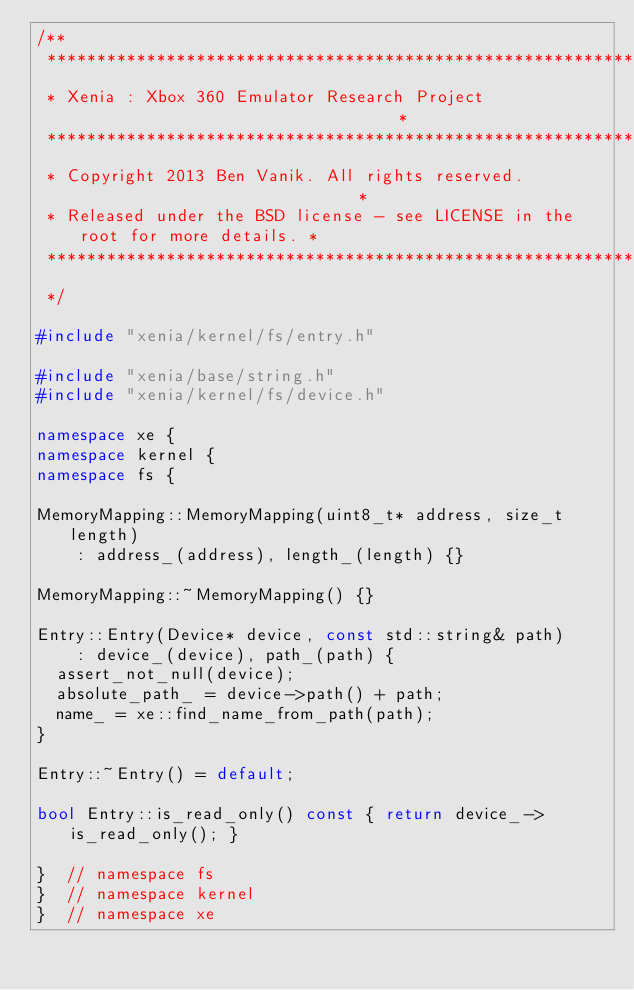Convert code to text. <code><loc_0><loc_0><loc_500><loc_500><_C++_>/**
 ******************************************************************************
 * Xenia : Xbox 360 Emulator Research Project                                 *
 ******************************************************************************
 * Copyright 2013 Ben Vanik. All rights reserved.                             *
 * Released under the BSD license - see LICENSE in the root for more details. *
 ******************************************************************************
 */

#include "xenia/kernel/fs/entry.h"

#include "xenia/base/string.h"
#include "xenia/kernel/fs/device.h"

namespace xe {
namespace kernel {
namespace fs {

MemoryMapping::MemoryMapping(uint8_t* address, size_t length)
    : address_(address), length_(length) {}

MemoryMapping::~MemoryMapping() {}

Entry::Entry(Device* device, const std::string& path)
    : device_(device), path_(path) {
  assert_not_null(device);
  absolute_path_ = device->path() + path;
  name_ = xe::find_name_from_path(path);
}

Entry::~Entry() = default;

bool Entry::is_read_only() const { return device_->is_read_only(); }

}  // namespace fs
}  // namespace kernel
}  // namespace xe
</code> 